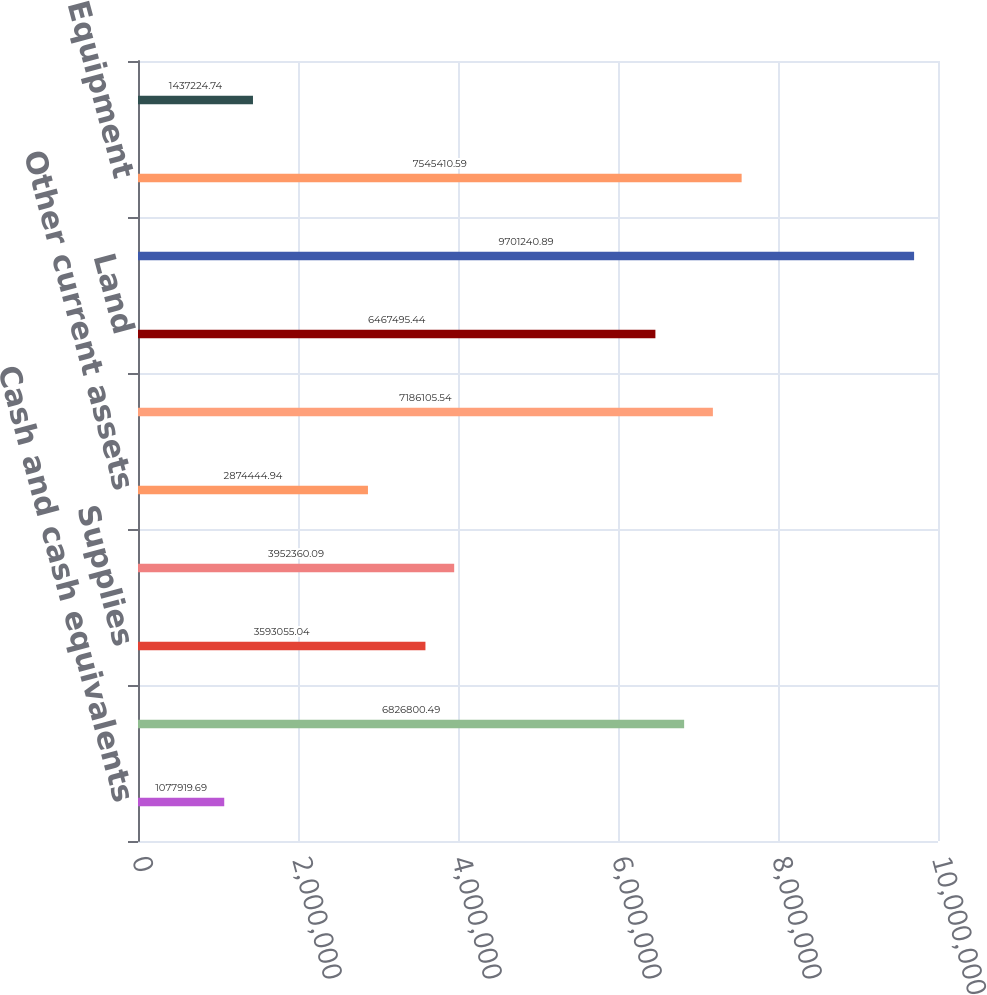<chart> <loc_0><loc_0><loc_500><loc_500><bar_chart><fcel>Cash and cash equivalents<fcel>Accounts receivable net<fcel>Supplies<fcel>Deferred income taxes<fcel>Other current assets<fcel>Total current assets<fcel>Land<fcel>Buildings and improvements<fcel>Equipment<fcel>Property under capital lease<nl><fcel>1.07792e+06<fcel>6.8268e+06<fcel>3.59306e+06<fcel>3.95236e+06<fcel>2.87444e+06<fcel>7.18611e+06<fcel>6.4675e+06<fcel>9.70124e+06<fcel>7.54541e+06<fcel>1.43722e+06<nl></chart> 